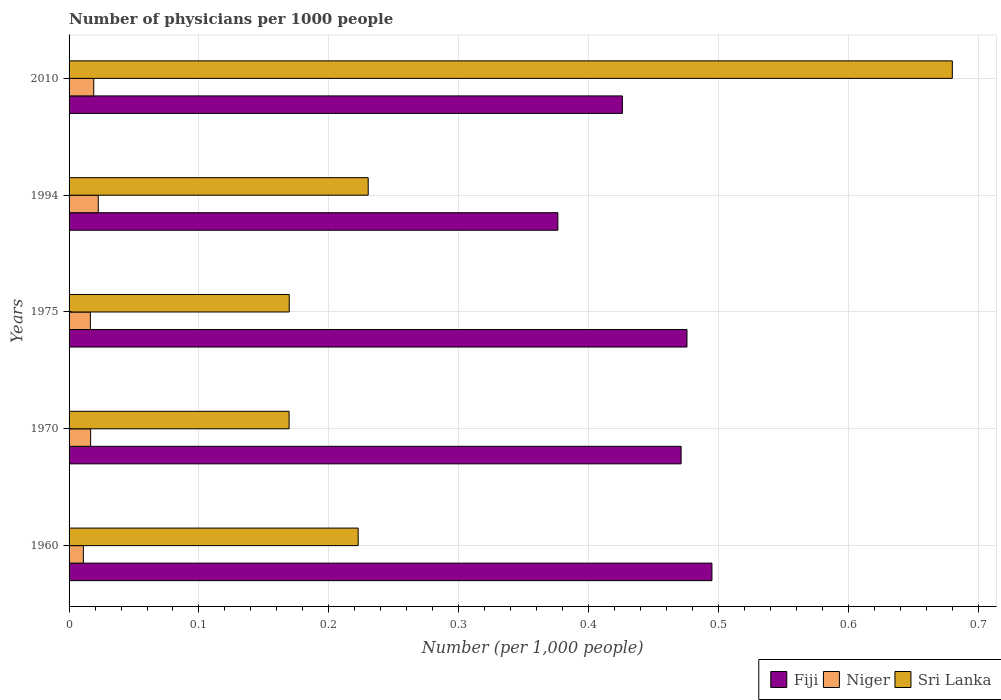How many different coloured bars are there?
Provide a succinct answer. 3. Are the number of bars per tick equal to the number of legend labels?
Provide a short and direct response. Yes. Are the number of bars on each tick of the Y-axis equal?
Provide a succinct answer. Yes. How many bars are there on the 3rd tick from the top?
Make the answer very short. 3. How many bars are there on the 1st tick from the bottom?
Your response must be concise. 3. What is the number of physicians in Niger in 1970?
Your answer should be very brief. 0.02. Across all years, what is the maximum number of physicians in Fiji?
Offer a very short reply. 0.49. Across all years, what is the minimum number of physicians in Niger?
Make the answer very short. 0.01. In which year was the number of physicians in Sri Lanka minimum?
Ensure brevity in your answer.  1970. What is the total number of physicians in Fiji in the graph?
Provide a short and direct response. 2.24. What is the difference between the number of physicians in Fiji in 1970 and that in 2010?
Keep it short and to the point. 0.05. What is the difference between the number of physicians in Fiji in 1970 and the number of physicians in Niger in 1960?
Your answer should be compact. 0.46. What is the average number of physicians in Niger per year?
Provide a short and direct response. 0.02. In the year 1970, what is the difference between the number of physicians in Niger and number of physicians in Fiji?
Provide a short and direct response. -0.45. In how many years, is the number of physicians in Fiji greater than 0.54 ?
Ensure brevity in your answer.  0. What is the ratio of the number of physicians in Niger in 1970 to that in 2010?
Your response must be concise. 0.87. Is the number of physicians in Sri Lanka in 1960 less than that in 1975?
Ensure brevity in your answer.  No. Is the difference between the number of physicians in Niger in 1970 and 1994 greater than the difference between the number of physicians in Fiji in 1970 and 1994?
Your answer should be very brief. No. What is the difference between the highest and the second highest number of physicians in Niger?
Your response must be concise. 0. What is the difference between the highest and the lowest number of physicians in Niger?
Make the answer very short. 0.01. What does the 3rd bar from the top in 1975 represents?
Offer a very short reply. Fiji. What does the 1st bar from the bottom in 1970 represents?
Your answer should be compact. Fiji. Are the values on the major ticks of X-axis written in scientific E-notation?
Provide a short and direct response. No. Does the graph contain any zero values?
Ensure brevity in your answer.  No. What is the title of the graph?
Your answer should be very brief. Number of physicians per 1000 people. What is the label or title of the X-axis?
Keep it short and to the point. Number (per 1,0 people). What is the Number (per 1,000 people) in Fiji in 1960?
Your answer should be very brief. 0.49. What is the Number (per 1,000 people) of Niger in 1960?
Ensure brevity in your answer.  0.01. What is the Number (per 1,000 people) in Sri Lanka in 1960?
Your answer should be compact. 0.22. What is the Number (per 1,000 people) in Fiji in 1970?
Keep it short and to the point. 0.47. What is the Number (per 1,000 people) in Niger in 1970?
Offer a very short reply. 0.02. What is the Number (per 1,000 people) in Sri Lanka in 1970?
Your response must be concise. 0.17. What is the Number (per 1,000 people) in Fiji in 1975?
Ensure brevity in your answer.  0.48. What is the Number (per 1,000 people) of Niger in 1975?
Your response must be concise. 0.02. What is the Number (per 1,000 people) in Sri Lanka in 1975?
Keep it short and to the point. 0.17. What is the Number (per 1,000 people) of Fiji in 1994?
Your answer should be very brief. 0.38. What is the Number (per 1,000 people) of Niger in 1994?
Offer a terse response. 0.02. What is the Number (per 1,000 people) of Sri Lanka in 1994?
Provide a short and direct response. 0.23. What is the Number (per 1,000 people) of Fiji in 2010?
Give a very brief answer. 0.43. What is the Number (per 1,000 people) in Niger in 2010?
Keep it short and to the point. 0.02. What is the Number (per 1,000 people) in Sri Lanka in 2010?
Make the answer very short. 0.68. Across all years, what is the maximum Number (per 1,000 people) of Fiji?
Make the answer very short. 0.49. Across all years, what is the maximum Number (per 1,000 people) in Niger?
Your answer should be very brief. 0.02. Across all years, what is the maximum Number (per 1,000 people) of Sri Lanka?
Your response must be concise. 0.68. Across all years, what is the minimum Number (per 1,000 people) of Fiji?
Offer a very short reply. 0.38. Across all years, what is the minimum Number (per 1,000 people) in Niger?
Your answer should be very brief. 0.01. Across all years, what is the minimum Number (per 1,000 people) in Sri Lanka?
Keep it short and to the point. 0.17. What is the total Number (per 1,000 people) in Fiji in the graph?
Keep it short and to the point. 2.24. What is the total Number (per 1,000 people) in Niger in the graph?
Ensure brevity in your answer.  0.09. What is the total Number (per 1,000 people) in Sri Lanka in the graph?
Ensure brevity in your answer.  1.47. What is the difference between the Number (per 1,000 people) in Fiji in 1960 and that in 1970?
Ensure brevity in your answer.  0.02. What is the difference between the Number (per 1,000 people) of Niger in 1960 and that in 1970?
Your response must be concise. -0.01. What is the difference between the Number (per 1,000 people) of Sri Lanka in 1960 and that in 1970?
Your answer should be compact. 0.05. What is the difference between the Number (per 1,000 people) of Fiji in 1960 and that in 1975?
Ensure brevity in your answer.  0.02. What is the difference between the Number (per 1,000 people) of Niger in 1960 and that in 1975?
Make the answer very short. -0.01. What is the difference between the Number (per 1,000 people) in Sri Lanka in 1960 and that in 1975?
Keep it short and to the point. 0.05. What is the difference between the Number (per 1,000 people) in Fiji in 1960 and that in 1994?
Offer a terse response. 0.12. What is the difference between the Number (per 1,000 people) of Niger in 1960 and that in 1994?
Provide a succinct answer. -0.01. What is the difference between the Number (per 1,000 people) in Sri Lanka in 1960 and that in 1994?
Offer a terse response. -0.01. What is the difference between the Number (per 1,000 people) in Fiji in 1960 and that in 2010?
Your response must be concise. 0.07. What is the difference between the Number (per 1,000 people) of Niger in 1960 and that in 2010?
Make the answer very short. -0.01. What is the difference between the Number (per 1,000 people) of Sri Lanka in 1960 and that in 2010?
Ensure brevity in your answer.  -0.46. What is the difference between the Number (per 1,000 people) of Fiji in 1970 and that in 1975?
Offer a terse response. -0. What is the difference between the Number (per 1,000 people) of Niger in 1970 and that in 1975?
Give a very brief answer. 0. What is the difference between the Number (per 1,000 people) in Sri Lanka in 1970 and that in 1975?
Offer a terse response. -0. What is the difference between the Number (per 1,000 people) in Fiji in 1970 and that in 1994?
Provide a succinct answer. 0.09. What is the difference between the Number (per 1,000 people) in Niger in 1970 and that in 1994?
Make the answer very short. -0.01. What is the difference between the Number (per 1,000 people) of Sri Lanka in 1970 and that in 1994?
Your answer should be very brief. -0.06. What is the difference between the Number (per 1,000 people) of Fiji in 1970 and that in 2010?
Offer a very short reply. 0.05. What is the difference between the Number (per 1,000 people) in Niger in 1970 and that in 2010?
Ensure brevity in your answer.  -0. What is the difference between the Number (per 1,000 people) of Sri Lanka in 1970 and that in 2010?
Your answer should be compact. -0.51. What is the difference between the Number (per 1,000 people) in Fiji in 1975 and that in 1994?
Your answer should be compact. 0.1. What is the difference between the Number (per 1,000 people) in Niger in 1975 and that in 1994?
Offer a terse response. -0.01. What is the difference between the Number (per 1,000 people) of Sri Lanka in 1975 and that in 1994?
Your answer should be very brief. -0.06. What is the difference between the Number (per 1,000 people) in Fiji in 1975 and that in 2010?
Your answer should be compact. 0.05. What is the difference between the Number (per 1,000 people) of Niger in 1975 and that in 2010?
Provide a short and direct response. -0. What is the difference between the Number (per 1,000 people) of Sri Lanka in 1975 and that in 2010?
Your answer should be compact. -0.51. What is the difference between the Number (per 1,000 people) of Fiji in 1994 and that in 2010?
Offer a very short reply. -0.05. What is the difference between the Number (per 1,000 people) of Niger in 1994 and that in 2010?
Your answer should be very brief. 0. What is the difference between the Number (per 1,000 people) of Sri Lanka in 1994 and that in 2010?
Provide a short and direct response. -0.45. What is the difference between the Number (per 1,000 people) in Fiji in 1960 and the Number (per 1,000 people) in Niger in 1970?
Your response must be concise. 0.48. What is the difference between the Number (per 1,000 people) in Fiji in 1960 and the Number (per 1,000 people) in Sri Lanka in 1970?
Your answer should be compact. 0.33. What is the difference between the Number (per 1,000 people) in Niger in 1960 and the Number (per 1,000 people) in Sri Lanka in 1970?
Give a very brief answer. -0.16. What is the difference between the Number (per 1,000 people) in Fiji in 1960 and the Number (per 1,000 people) in Niger in 1975?
Ensure brevity in your answer.  0.48. What is the difference between the Number (per 1,000 people) in Fiji in 1960 and the Number (per 1,000 people) in Sri Lanka in 1975?
Offer a very short reply. 0.33. What is the difference between the Number (per 1,000 people) in Niger in 1960 and the Number (per 1,000 people) in Sri Lanka in 1975?
Keep it short and to the point. -0.16. What is the difference between the Number (per 1,000 people) of Fiji in 1960 and the Number (per 1,000 people) of Niger in 1994?
Offer a terse response. 0.47. What is the difference between the Number (per 1,000 people) in Fiji in 1960 and the Number (per 1,000 people) in Sri Lanka in 1994?
Ensure brevity in your answer.  0.26. What is the difference between the Number (per 1,000 people) of Niger in 1960 and the Number (per 1,000 people) of Sri Lanka in 1994?
Your answer should be very brief. -0.22. What is the difference between the Number (per 1,000 people) of Fiji in 1960 and the Number (per 1,000 people) of Niger in 2010?
Offer a terse response. 0.48. What is the difference between the Number (per 1,000 people) in Fiji in 1960 and the Number (per 1,000 people) in Sri Lanka in 2010?
Make the answer very short. -0.19. What is the difference between the Number (per 1,000 people) in Niger in 1960 and the Number (per 1,000 people) in Sri Lanka in 2010?
Keep it short and to the point. -0.67. What is the difference between the Number (per 1,000 people) in Fiji in 1970 and the Number (per 1,000 people) in Niger in 1975?
Make the answer very short. 0.45. What is the difference between the Number (per 1,000 people) in Fiji in 1970 and the Number (per 1,000 people) in Sri Lanka in 1975?
Your response must be concise. 0.3. What is the difference between the Number (per 1,000 people) in Niger in 1970 and the Number (per 1,000 people) in Sri Lanka in 1975?
Offer a very short reply. -0.15. What is the difference between the Number (per 1,000 people) of Fiji in 1970 and the Number (per 1,000 people) of Niger in 1994?
Your response must be concise. 0.45. What is the difference between the Number (per 1,000 people) of Fiji in 1970 and the Number (per 1,000 people) of Sri Lanka in 1994?
Make the answer very short. 0.24. What is the difference between the Number (per 1,000 people) of Niger in 1970 and the Number (per 1,000 people) of Sri Lanka in 1994?
Give a very brief answer. -0.21. What is the difference between the Number (per 1,000 people) in Fiji in 1970 and the Number (per 1,000 people) in Niger in 2010?
Give a very brief answer. 0.45. What is the difference between the Number (per 1,000 people) of Fiji in 1970 and the Number (per 1,000 people) of Sri Lanka in 2010?
Make the answer very short. -0.21. What is the difference between the Number (per 1,000 people) of Niger in 1970 and the Number (per 1,000 people) of Sri Lanka in 2010?
Make the answer very short. -0.66. What is the difference between the Number (per 1,000 people) in Fiji in 1975 and the Number (per 1,000 people) in Niger in 1994?
Provide a succinct answer. 0.45. What is the difference between the Number (per 1,000 people) in Fiji in 1975 and the Number (per 1,000 people) in Sri Lanka in 1994?
Your answer should be very brief. 0.25. What is the difference between the Number (per 1,000 people) in Niger in 1975 and the Number (per 1,000 people) in Sri Lanka in 1994?
Ensure brevity in your answer.  -0.21. What is the difference between the Number (per 1,000 people) in Fiji in 1975 and the Number (per 1,000 people) in Niger in 2010?
Your answer should be very brief. 0.46. What is the difference between the Number (per 1,000 people) of Fiji in 1975 and the Number (per 1,000 people) of Sri Lanka in 2010?
Your answer should be compact. -0.2. What is the difference between the Number (per 1,000 people) in Niger in 1975 and the Number (per 1,000 people) in Sri Lanka in 2010?
Your response must be concise. -0.66. What is the difference between the Number (per 1,000 people) in Fiji in 1994 and the Number (per 1,000 people) in Niger in 2010?
Provide a succinct answer. 0.36. What is the difference between the Number (per 1,000 people) of Fiji in 1994 and the Number (per 1,000 people) of Sri Lanka in 2010?
Your response must be concise. -0.3. What is the difference between the Number (per 1,000 people) of Niger in 1994 and the Number (per 1,000 people) of Sri Lanka in 2010?
Provide a short and direct response. -0.66. What is the average Number (per 1,000 people) of Fiji per year?
Your answer should be compact. 0.45. What is the average Number (per 1,000 people) of Niger per year?
Give a very brief answer. 0.02. What is the average Number (per 1,000 people) in Sri Lanka per year?
Your answer should be very brief. 0.29. In the year 1960, what is the difference between the Number (per 1,000 people) in Fiji and Number (per 1,000 people) in Niger?
Give a very brief answer. 0.48. In the year 1960, what is the difference between the Number (per 1,000 people) of Fiji and Number (per 1,000 people) of Sri Lanka?
Make the answer very short. 0.27. In the year 1960, what is the difference between the Number (per 1,000 people) in Niger and Number (per 1,000 people) in Sri Lanka?
Provide a short and direct response. -0.21. In the year 1970, what is the difference between the Number (per 1,000 people) of Fiji and Number (per 1,000 people) of Niger?
Give a very brief answer. 0.45. In the year 1970, what is the difference between the Number (per 1,000 people) in Fiji and Number (per 1,000 people) in Sri Lanka?
Your answer should be very brief. 0.3. In the year 1970, what is the difference between the Number (per 1,000 people) in Niger and Number (per 1,000 people) in Sri Lanka?
Your answer should be very brief. -0.15. In the year 1975, what is the difference between the Number (per 1,000 people) in Fiji and Number (per 1,000 people) in Niger?
Your answer should be very brief. 0.46. In the year 1975, what is the difference between the Number (per 1,000 people) of Fiji and Number (per 1,000 people) of Sri Lanka?
Provide a short and direct response. 0.31. In the year 1975, what is the difference between the Number (per 1,000 people) of Niger and Number (per 1,000 people) of Sri Lanka?
Offer a very short reply. -0.15. In the year 1994, what is the difference between the Number (per 1,000 people) in Fiji and Number (per 1,000 people) in Niger?
Your answer should be compact. 0.35. In the year 1994, what is the difference between the Number (per 1,000 people) of Fiji and Number (per 1,000 people) of Sri Lanka?
Your response must be concise. 0.15. In the year 1994, what is the difference between the Number (per 1,000 people) in Niger and Number (per 1,000 people) in Sri Lanka?
Offer a terse response. -0.21. In the year 2010, what is the difference between the Number (per 1,000 people) in Fiji and Number (per 1,000 people) in Niger?
Offer a very short reply. 0.41. In the year 2010, what is the difference between the Number (per 1,000 people) of Fiji and Number (per 1,000 people) of Sri Lanka?
Your response must be concise. -0.25. In the year 2010, what is the difference between the Number (per 1,000 people) of Niger and Number (per 1,000 people) of Sri Lanka?
Your answer should be compact. -0.66. What is the ratio of the Number (per 1,000 people) in Fiji in 1960 to that in 1970?
Offer a very short reply. 1.05. What is the ratio of the Number (per 1,000 people) in Niger in 1960 to that in 1970?
Offer a terse response. 0.66. What is the ratio of the Number (per 1,000 people) in Sri Lanka in 1960 to that in 1970?
Keep it short and to the point. 1.31. What is the ratio of the Number (per 1,000 people) of Fiji in 1960 to that in 1975?
Provide a succinct answer. 1.04. What is the ratio of the Number (per 1,000 people) of Niger in 1960 to that in 1975?
Offer a terse response. 0.67. What is the ratio of the Number (per 1,000 people) of Sri Lanka in 1960 to that in 1975?
Your response must be concise. 1.31. What is the ratio of the Number (per 1,000 people) of Fiji in 1960 to that in 1994?
Keep it short and to the point. 1.32. What is the ratio of the Number (per 1,000 people) in Niger in 1960 to that in 1994?
Your response must be concise. 0.49. What is the ratio of the Number (per 1,000 people) in Sri Lanka in 1960 to that in 1994?
Your response must be concise. 0.97. What is the ratio of the Number (per 1,000 people) of Fiji in 1960 to that in 2010?
Make the answer very short. 1.16. What is the ratio of the Number (per 1,000 people) of Niger in 1960 to that in 2010?
Offer a terse response. 0.58. What is the ratio of the Number (per 1,000 people) in Sri Lanka in 1960 to that in 2010?
Give a very brief answer. 0.33. What is the ratio of the Number (per 1,000 people) in Niger in 1970 to that in 1975?
Provide a short and direct response. 1.01. What is the ratio of the Number (per 1,000 people) of Sri Lanka in 1970 to that in 1975?
Provide a succinct answer. 1. What is the ratio of the Number (per 1,000 people) in Fiji in 1970 to that in 1994?
Ensure brevity in your answer.  1.25. What is the ratio of the Number (per 1,000 people) in Niger in 1970 to that in 1994?
Keep it short and to the point. 0.74. What is the ratio of the Number (per 1,000 people) in Sri Lanka in 1970 to that in 1994?
Give a very brief answer. 0.74. What is the ratio of the Number (per 1,000 people) of Fiji in 1970 to that in 2010?
Provide a succinct answer. 1.11. What is the ratio of the Number (per 1,000 people) in Niger in 1970 to that in 2010?
Offer a terse response. 0.87. What is the ratio of the Number (per 1,000 people) of Sri Lanka in 1970 to that in 2010?
Keep it short and to the point. 0.25. What is the ratio of the Number (per 1,000 people) of Fiji in 1975 to that in 1994?
Give a very brief answer. 1.26. What is the ratio of the Number (per 1,000 people) in Niger in 1975 to that in 1994?
Offer a terse response. 0.73. What is the ratio of the Number (per 1,000 people) of Sri Lanka in 1975 to that in 1994?
Provide a short and direct response. 0.74. What is the ratio of the Number (per 1,000 people) of Fiji in 1975 to that in 2010?
Offer a terse response. 1.12. What is the ratio of the Number (per 1,000 people) of Niger in 1975 to that in 2010?
Provide a succinct answer. 0.86. What is the ratio of the Number (per 1,000 people) of Sri Lanka in 1975 to that in 2010?
Provide a short and direct response. 0.25. What is the ratio of the Number (per 1,000 people) of Fiji in 1994 to that in 2010?
Give a very brief answer. 0.88. What is the ratio of the Number (per 1,000 people) of Niger in 1994 to that in 2010?
Provide a short and direct response. 1.18. What is the ratio of the Number (per 1,000 people) in Sri Lanka in 1994 to that in 2010?
Offer a terse response. 0.34. What is the difference between the highest and the second highest Number (per 1,000 people) of Fiji?
Ensure brevity in your answer.  0.02. What is the difference between the highest and the second highest Number (per 1,000 people) in Niger?
Offer a very short reply. 0. What is the difference between the highest and the second highest Number (per 1,000 people) of Sri Lanka?
Offer a terse response. 0.45. What is the difference between the highest and the lowest Number (per 1,000 people) in Fiji?
Provide a succinct answer. 0.12. What is the difference between the highest and the lowest Number (per 1,000 people) of Niger?
Your response must be concise. 0.01. What is the difference between the highest and the lowest Number (per 1,000 people) of Sri Lanka?
Your response must be concise. 0.51. 